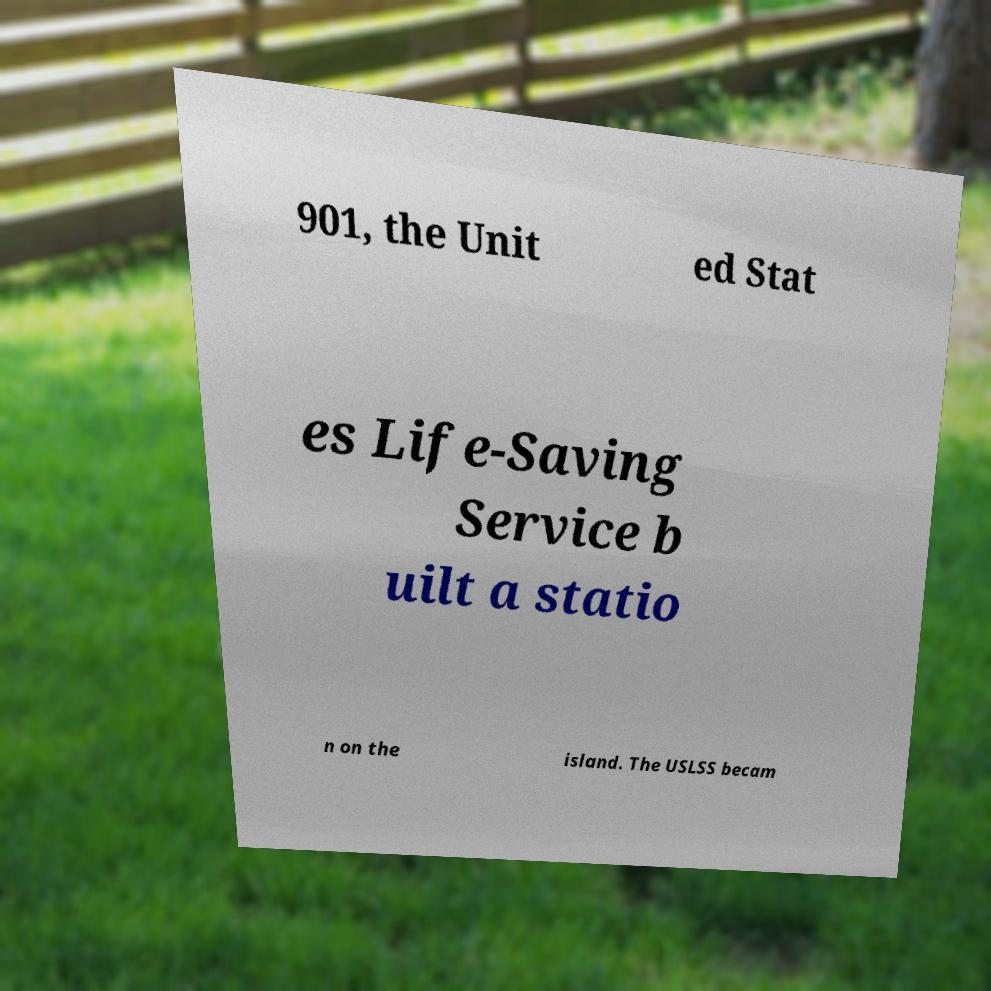Can you read and provide the text displayed in the image?This photo seems to have some interesting text. Can you extract and type it out for me? 901, the Unit ed Stat es Life-Saving Service b uilt a statio n on the island. The USLSS becam 